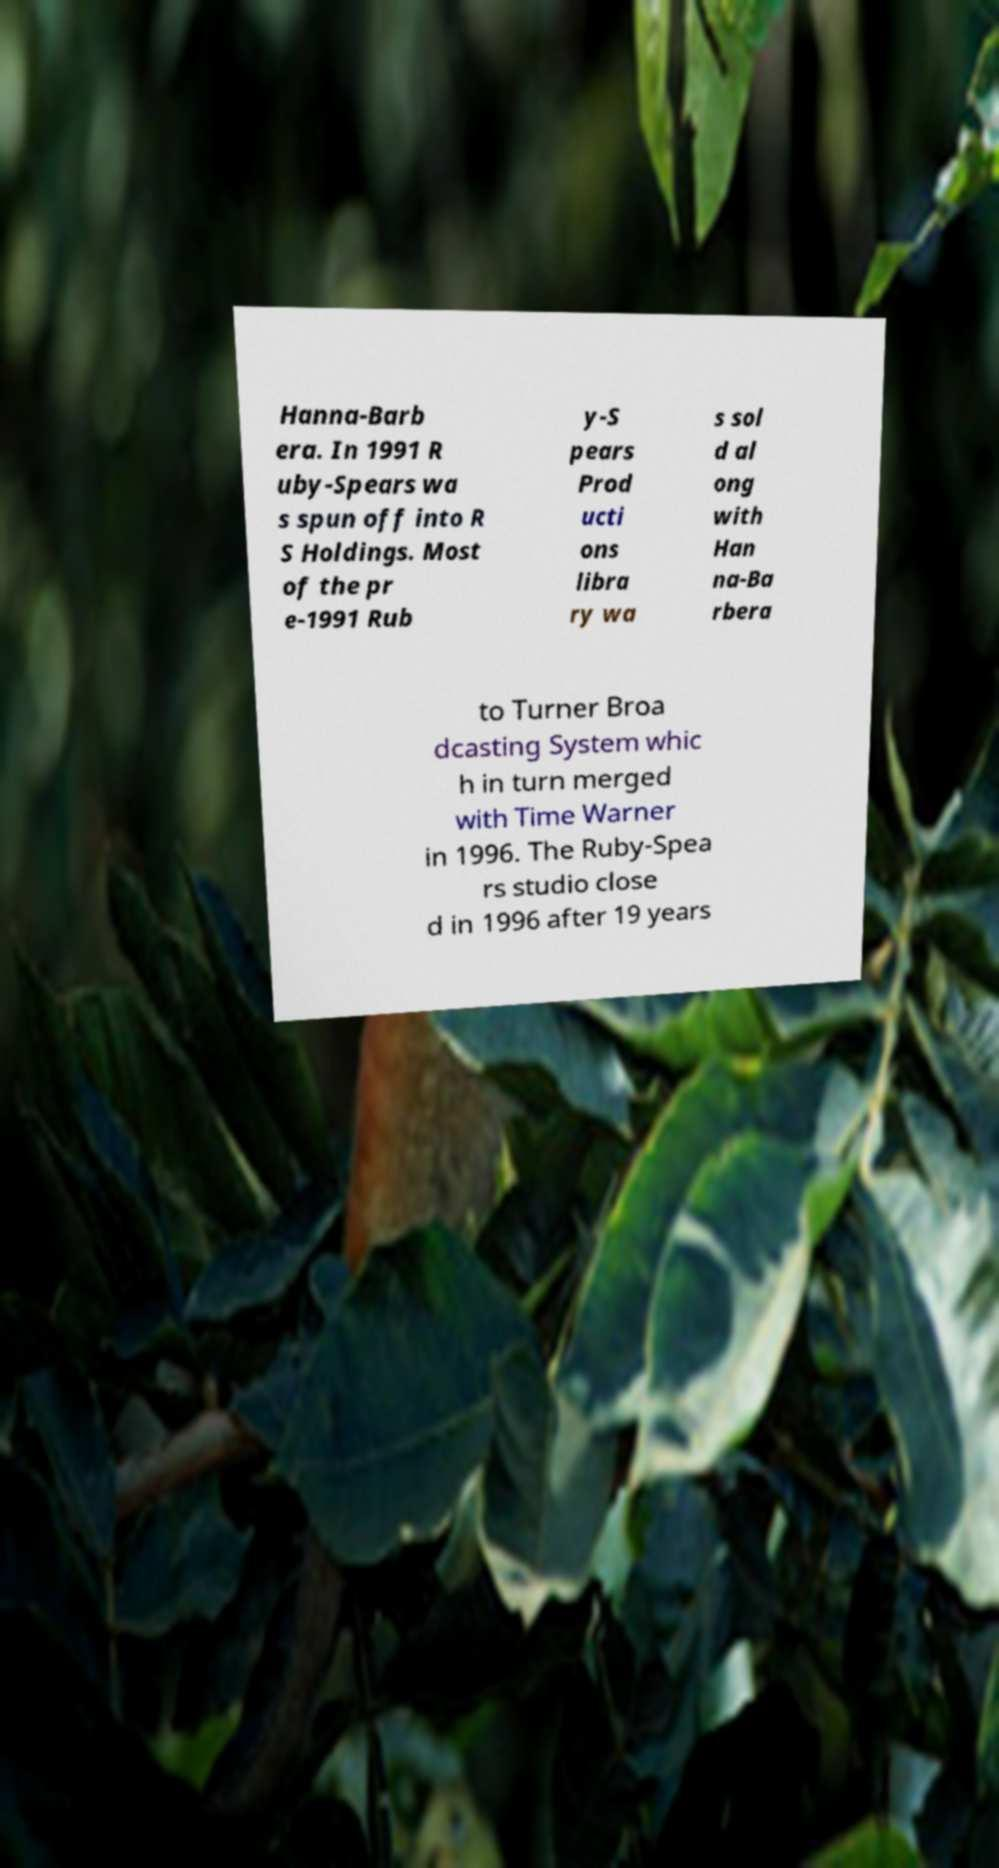There's text embedded in this image that I need extracted. Can you transcribe it verbatim? Hanna-Barb era. In 1991 R uby-Spears wa s spun off into R S Holdings. Most of the pr e-1991 Rub y-S pears Prod ucti ons libra ry wa s sol d al ong with Han na-Ba rbera to Turner Broa dcasting System whic h in turn merged with Time Warner in 1996. The Ruby-Spea rs studio close d in 1996 after 19 years 